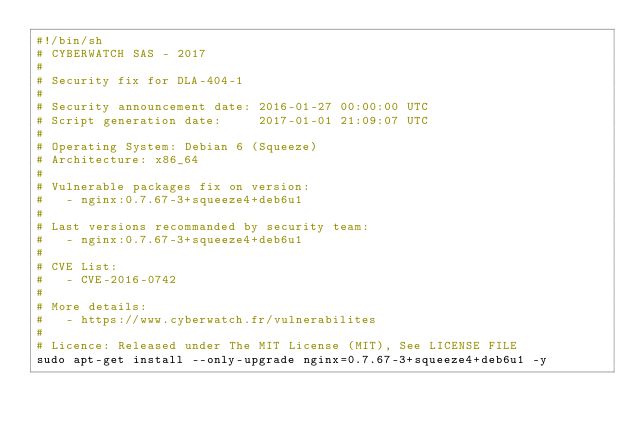Convert code to text. <code><loc_0><loc_0><loc_500><loc_500><_Bash_>#!/bin/sh
# CYBERWATCH SAS - 2017
#
# Security fix for DLA-404-1
#
# Security announcement date: 2016-01-27 00:00:00 UTC
# Script generation date:     2017-01-01 21:09:07 UTC
#
# Operating System: Debian 6 (Squeeze)
# Architecture: x86_64
#
# Vulnerable packages fix on version:
#   - nginx:0.7.67-3+squeeze4+deb6u1
#
# Last versions recommanded by security team:
#   - nginx:0.7.67-3+squeeze4+deb6u1
#
# CVE List:
#   - CVE-2016-0742
#
# More details:
#   - https://www.cyberwatch.fr/vulnerabilites
#
# Licence: Released under The MIT License (MIT), See LICENSE FILE
sudo apt-get install --only-upgrade nginx=0.7.67-3+squeeze4+deb6u1 -y
</code> 